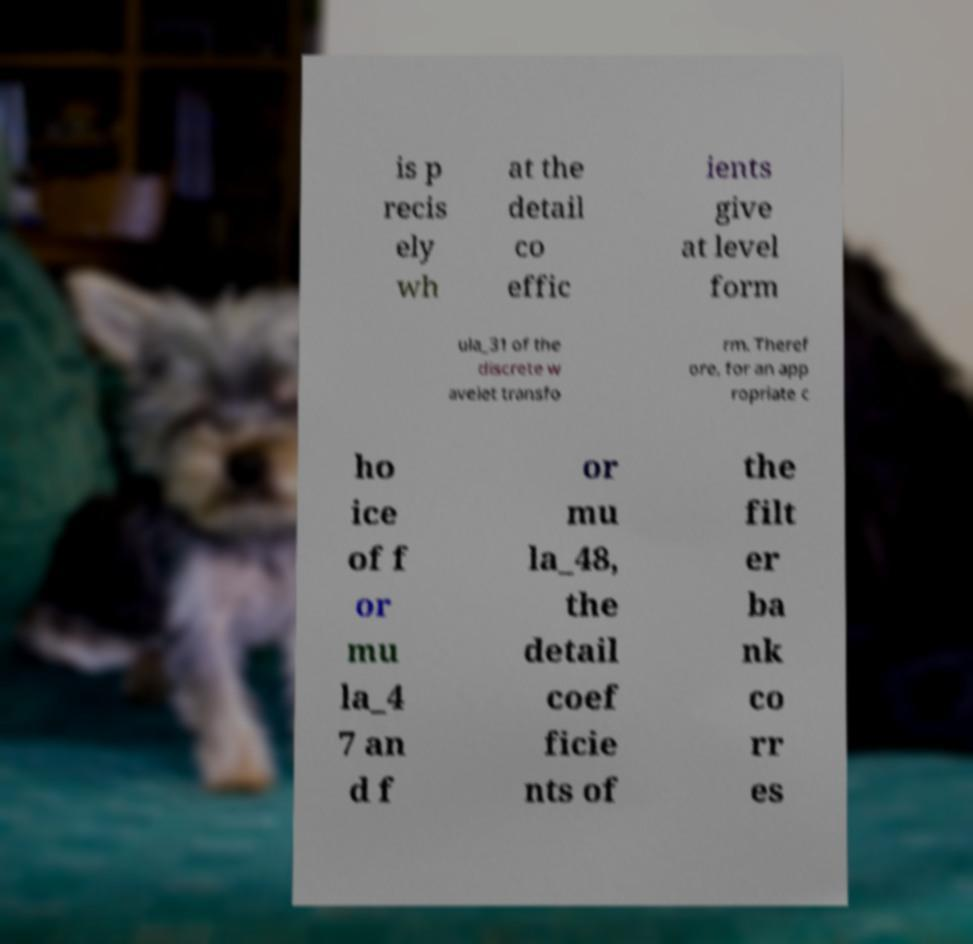For documentation purposes, I need the text within this image transcribed. Could you provide that? is p recis ely wh at the detail co effic ients give at level form ula_31 of the discrete w avelet transfo rm. Theref ore, for an app ropriate c ho ice of f or mu la_4 7 an d f or mu la_48, the detail coef ficie nts of the filt er ba nk co rr es 